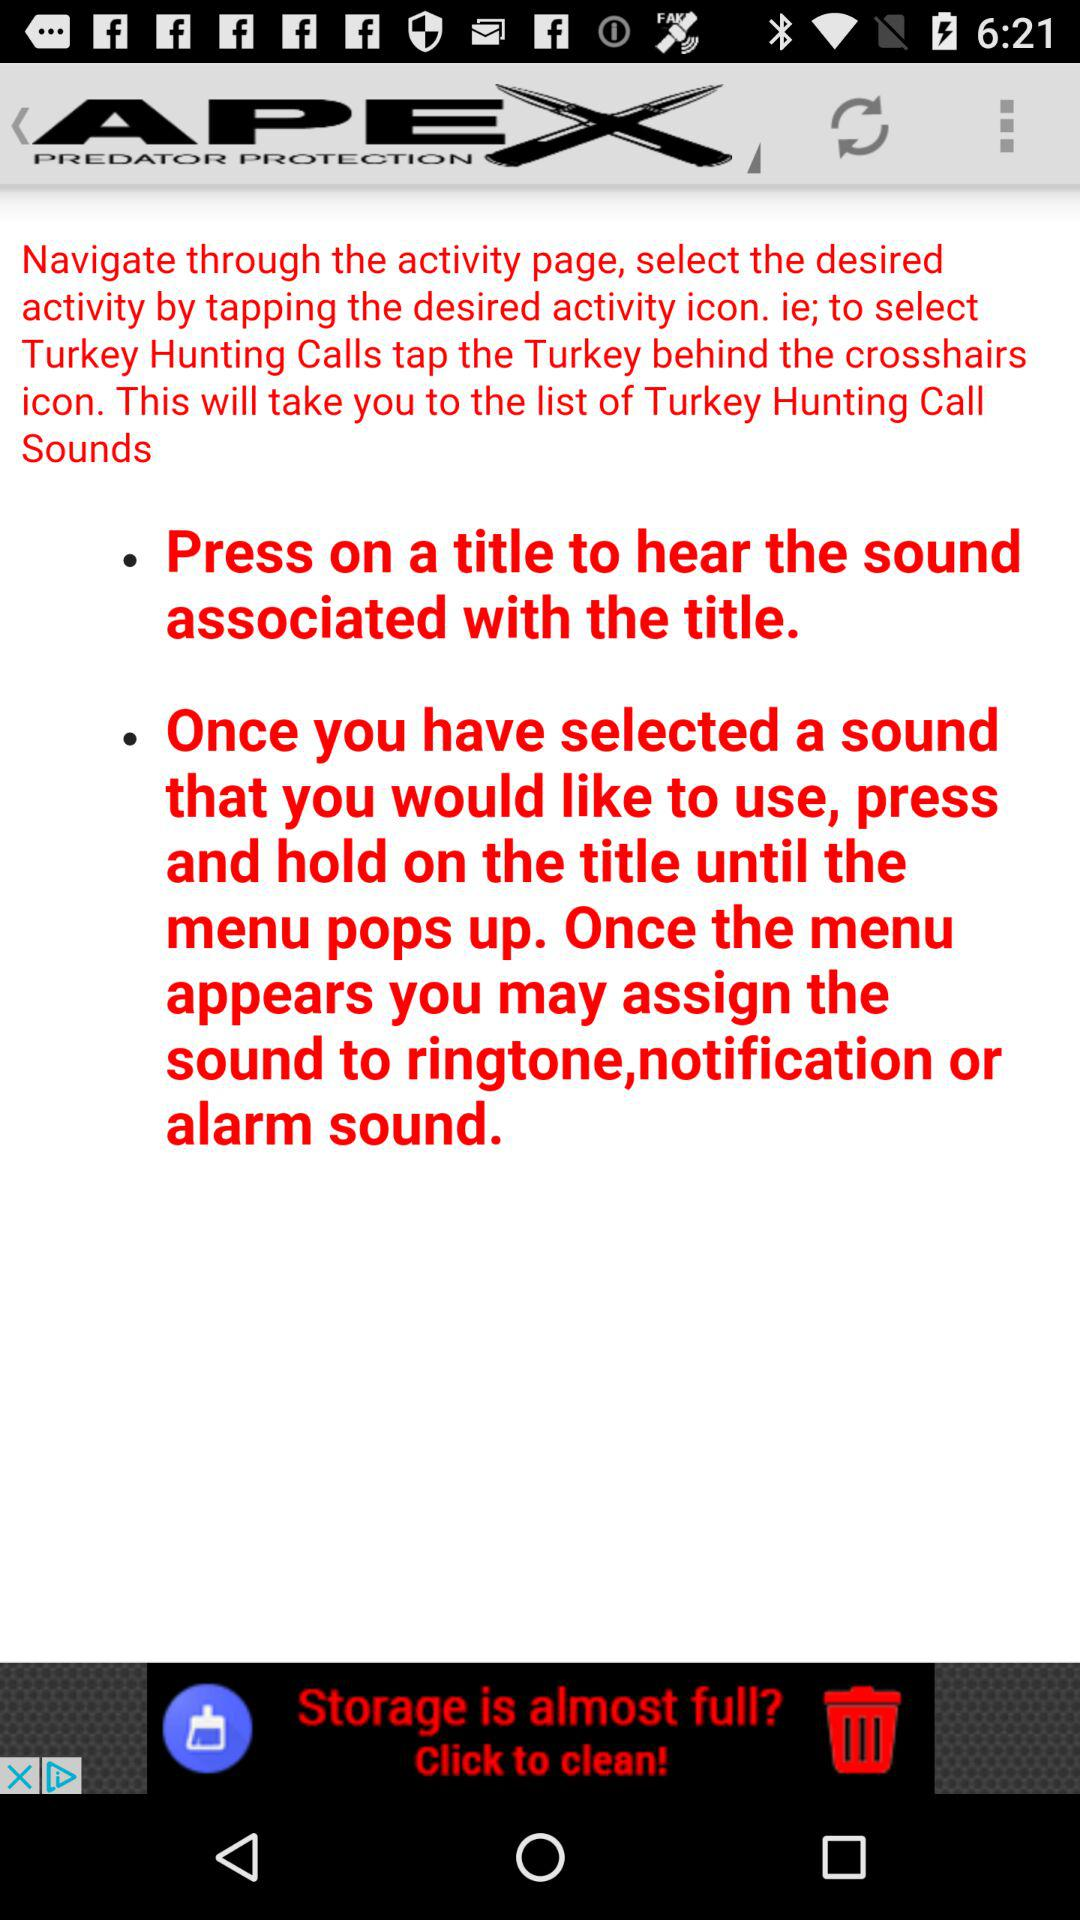What is the name of the application?
When the provided information is insufficient, respond with <no answer>. <no answer> 